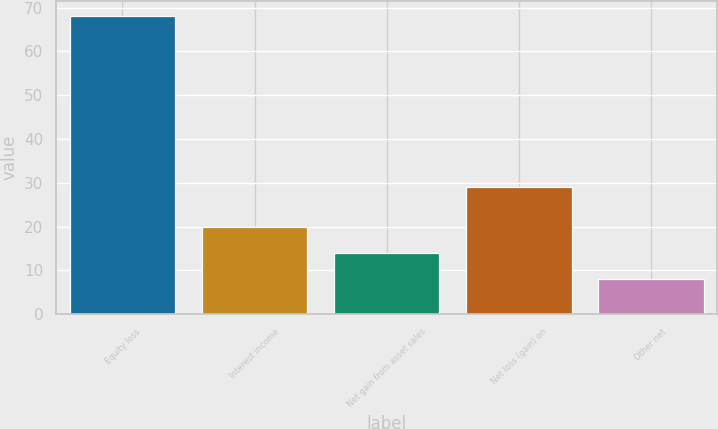Convert chart to OTSL. <chart><loc_0><loc_0><loc_500><loc_500><bar_chart><fcel>Equity loss<fcel>Interest income<fcel>Net gain from asset sales<fcel>Net loss (gain) on<fcel>Other net<nl><fcel>68<fcel>20<fcel>14<fcel>29<fcel>8<nl></chart> 